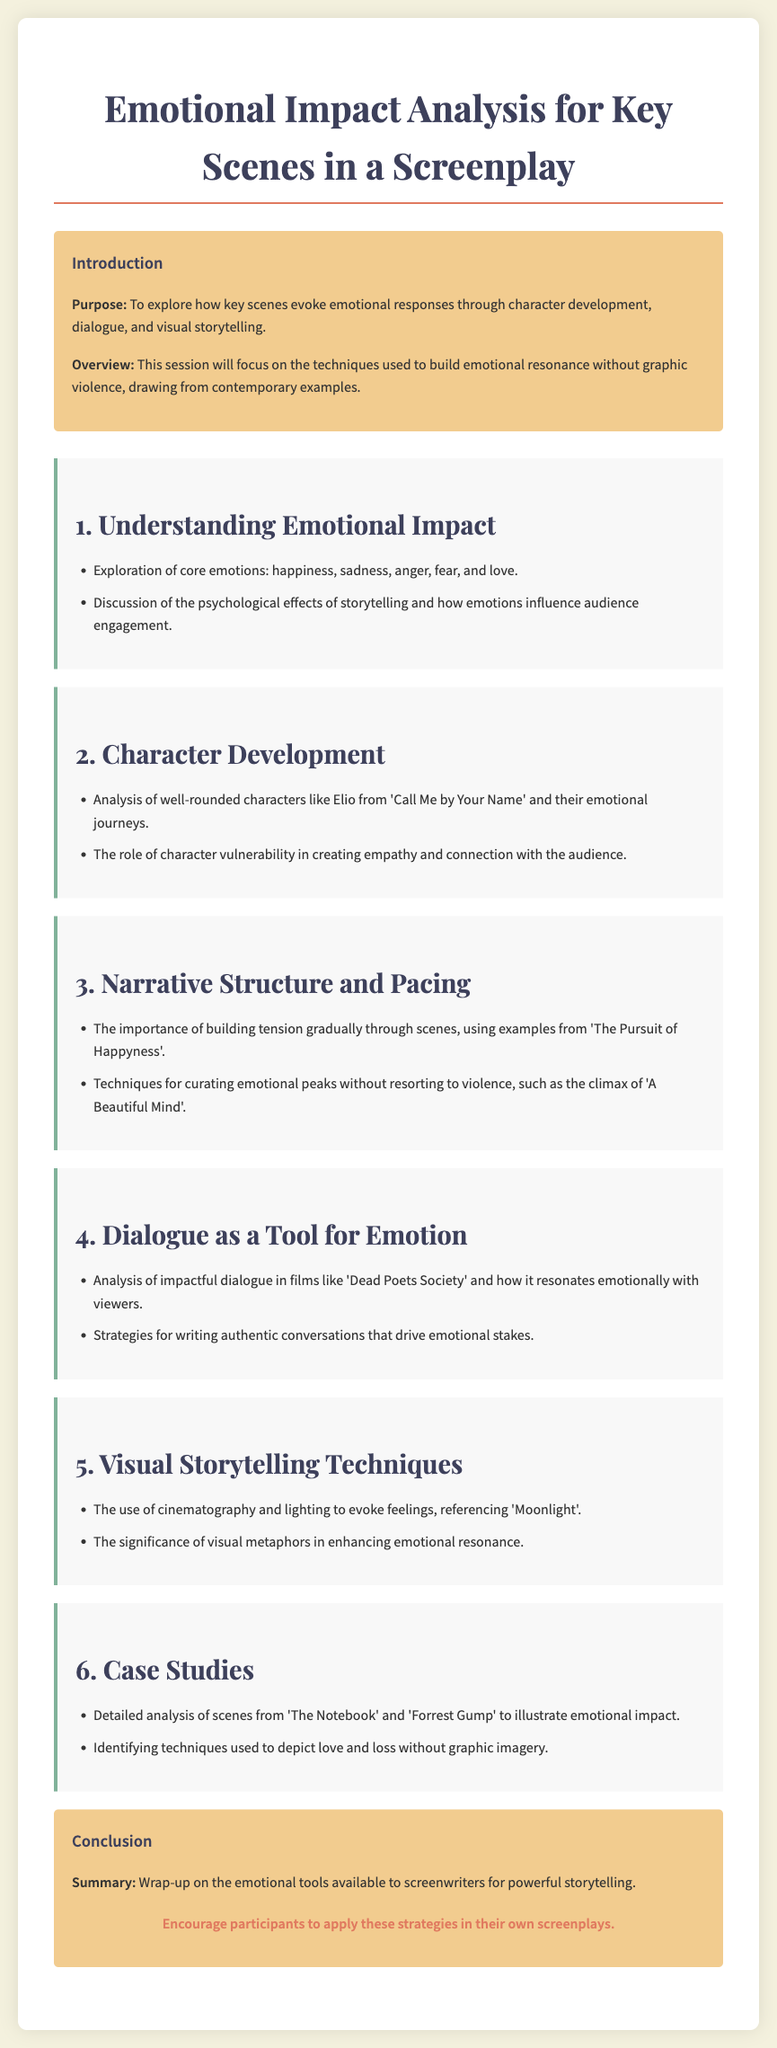What is the purpose of the document? The purpose is to explore how key scenes evoke emotional responses through character development, dialogue, and visual storytelling.
Answer: To explore emotional responses What key films are referenced for character development analysis? The document mentions "Call Me by Your Name" as an example of character analysis.
Answer: Call Me by Your Name What is the focus of the dialogue section? The dialogue section focuses on impactful dialogue in films like "Dead Poets Society" and writing authentic conversations.
Answer: Impactful dialogue Which technique is emphasized in the narrative structure section? It emphasizes the importance of building tension gradually through scenes.
Answer: Building tension gradually What emotional tools are discussed for impactful storytelling? The conclusion wraps up on the emotional tools available to screenwriters.
Answer: Emotional tools How many sections are outlined in the document? There are six sections outlined in the document.
Answer: Six What is the significance of visual metaphors according to the document? The document states that visual metaphors enhance emotional resonance.
Answer: Enhance emotional resonance Which two films are analyzed in the case studies section? The case studies section analyzes scenes from "The Notebook" and "Forrest Gump."
Answer: The Notebook and Forrest Gump What is the call-to-action for participants at the end of the document? The call-to-action encourages participants to apply these strategies in their own screenplays.
Answer: Apply strategies in screenplays 